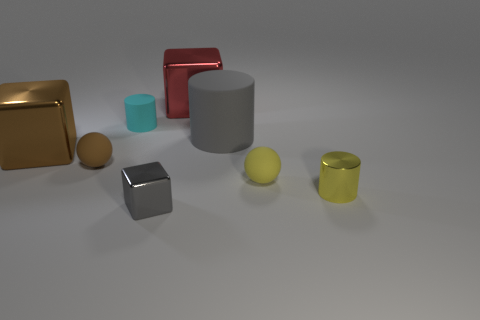Can you describe the colors and shapes of the objects nearest to the left edge of the image? Certainly! The object nearest to the left edge of the image is a large, gold-colored cube. Next to it, slightly further to the right, is a smaller, reddish rectangular block that seems to be leaning against the cube. 